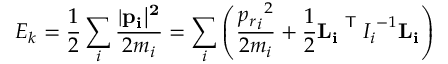Convert formula to latex. <formula><loc_0><loc_0><loc_500><loc_500>E _ { k } = { \frac { 1 } { 2 } } \sum _ { i } { \frac { | { { p } _ { i } | ^ { 2 } } } { 2 m _ { i } } } = \sum _ { i } \left ( { \frac { { { p _ { r } } _ { i } } ^ { 2 } } { 2 m _ { i } } } + { \frac { 1 } { 2 } } { { L } _ { i } } ^ { T } { I _ { i } } ^ { - 1 } { { L } _ { i } } \right )</formula> 